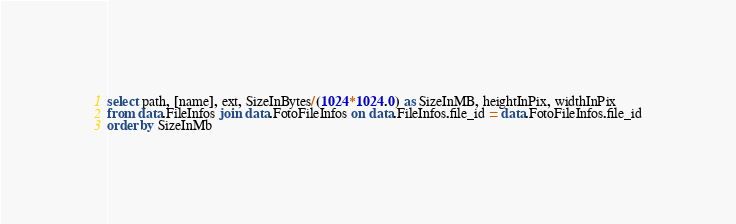<code> <loc_0><loc_0><loc_500><loc_500><_SQL_>select path, [name], ext, SizeInBytes/(1024*1024.0) as SizeInMB, heightInPix, widthInPix
from data.FileInfos join data.FotoFileInfos on data.FileInfos.file_id = data.FotoFileInfos.file_id
order by SizeInMb
</code> 